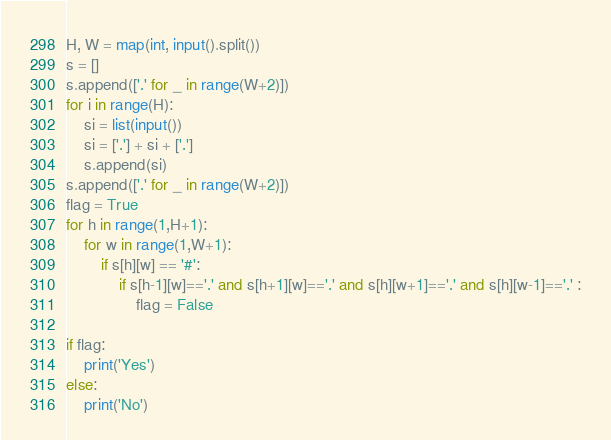Convert code to text. <code><loc_0><loc_0><loc_500><loc_500><_Python_>H, W = map(int, input().split())
s = []
s.append(['.' for _ in range(W+2)])
for i in range(H):
    si = list(input())
    si = ['.'] + si + ['.']
    s.append(si)
s.append(['.' for _ in range(W+2)])
flag = True
for h in range(1,H+1):
    for w in range(1,W+1):
        if s[h][w] == '#':
            if s[h-1][w]=='.' and s[h+1][w]=='.' and s[h][w+1]=='.' and s[h][w-1]=='.' :
                flag = False

if flag:
    print('Yes')
else:
    print('No')
</code> 